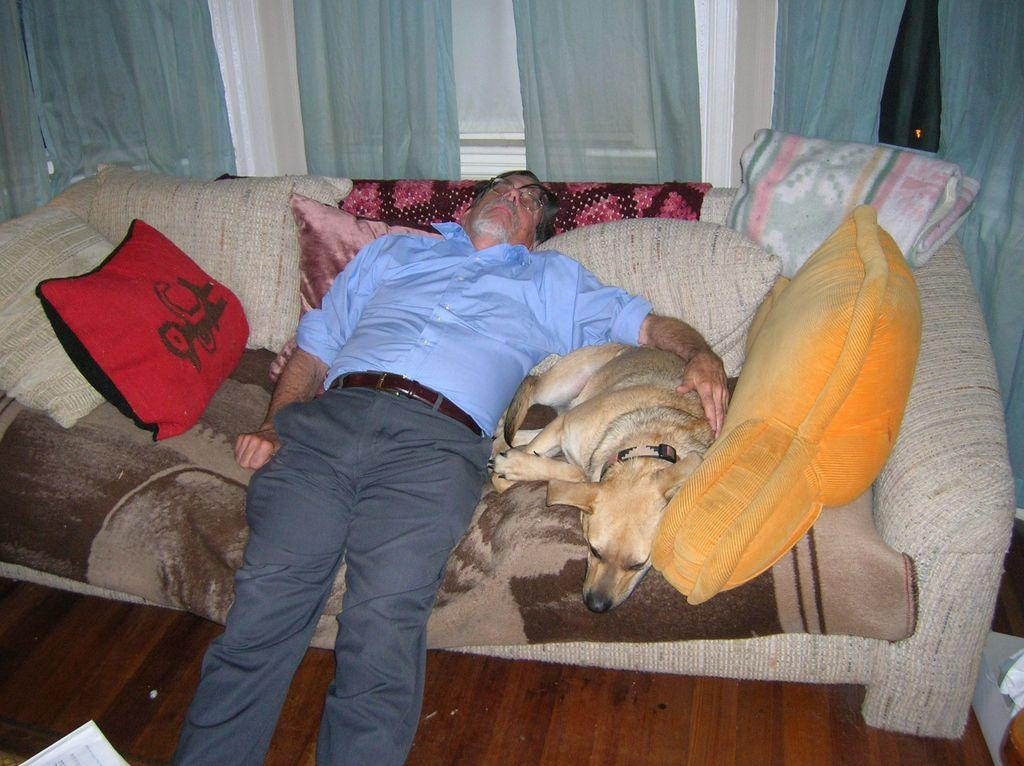Who or what is the main subject in the image? There is a person in the image. What is the person doing in the image? The person is lying on a sofa. Is there any interaction between the person and another living being in the image? Yes, the person is keeping their hand on a dog. What can be seen in the background of the image? There are curtains in the background of the image. What type of system is the person using to communicate with their grandfather in the image? There is no mention of a grandfather or any communication system in the image. 